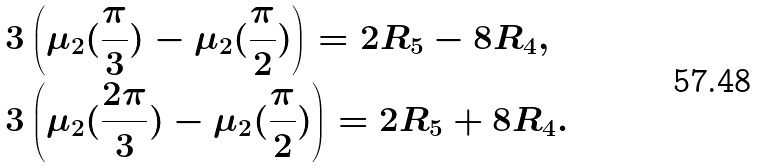<formula> <loc_0><loc_0><loc_500><loc_500>& 3 \left ( \mu _ { 2 } ( \frac { \pi } { 3 } ) - \mu _ { 2 } ( \frac { \pi } { 2 } ) \right ) = 2 R _ { 5 } - 8 R _ { 4 } , \\ & 3 \left ( \mu _ { 2 } ( \frac { 2 \pi } { 3 } ) - \mu _ { 2 } ( \frac { \pi } { 2 } ) \right ) = 2 R _ { 5 } + 8 R _ { 4 } .</formula> 